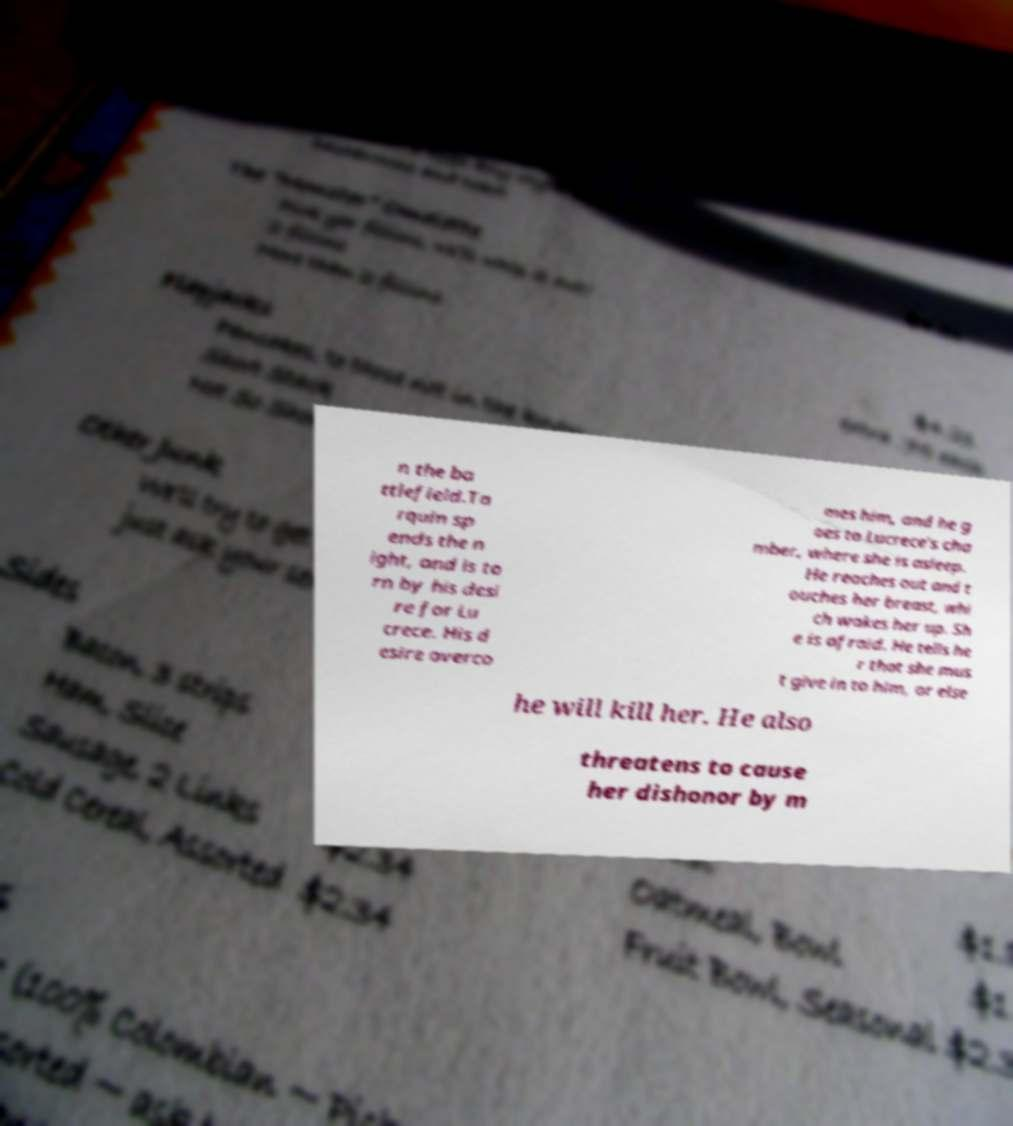Can you read and provide the text displayed in the image?This photo seems to have some interesting text. Can you extract and type it out for me? n the ba ttlefield.Ta rquin sp ends the n ight, and is to rn by his desi re for Lu crece. His d esire overco mes him, and he g oes to Lucrece's cha mber, where she is asleep. He reaches out and t ouches her breast, whi ch wakes her up. Sh e is afraid. He tells he r that she mus t give in to him, or else he will kill her. He also threatens to cause her dishonor by m 